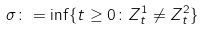Convert formula to latex. <formula><loc_0><loc_0><loc_500><loc_500>\sigma \colon = \inf \{ t \geq 0 \colon Z ^ { 1 } _ { t } \neq Z ^ { 2 } _ { t } \}</formula> 